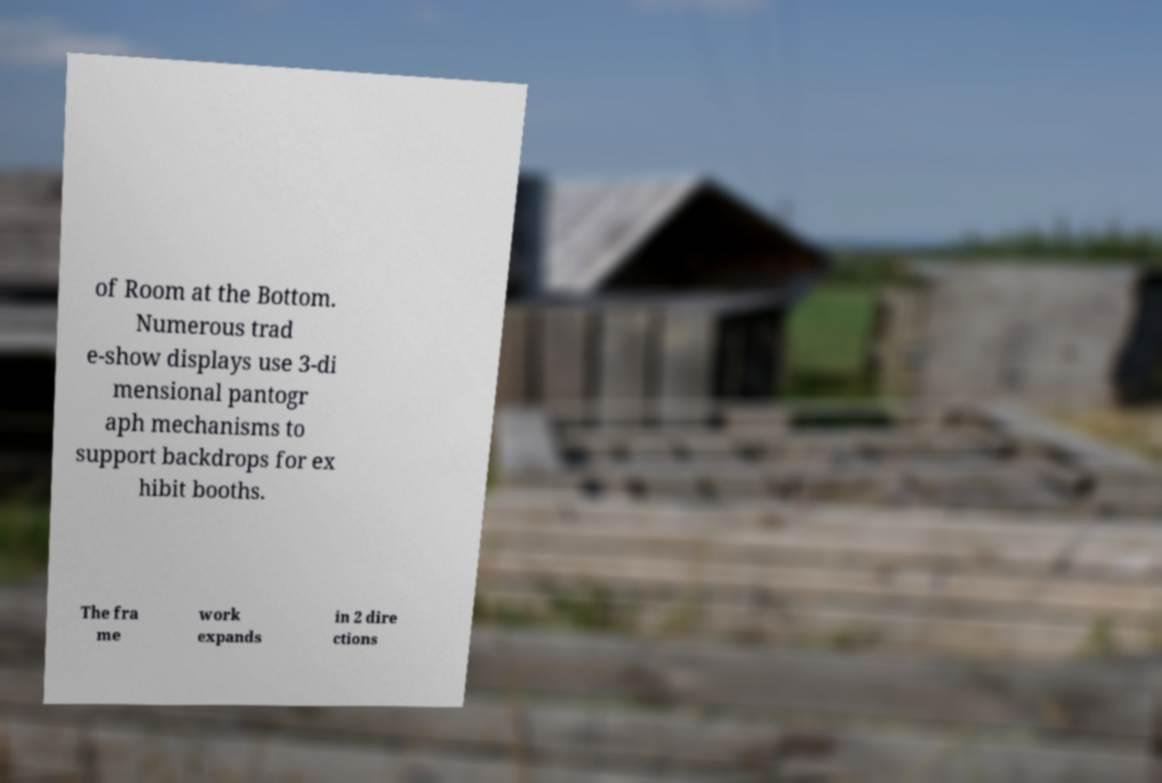There's text embedded in this image that I need extracted. Can you transcribe it verbatim? of Room at the Bottom. Numerous trad e-show displays use 3-di mensional pantogr aph mechanisms to support backdrops for ex hibit booths. The fra me work expands in 2 dire ctions 